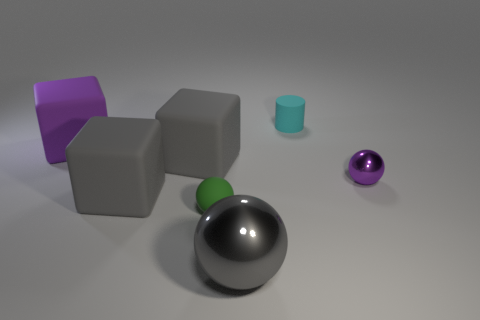What size is the cube that is the same color as the small shiny object?
Give a very brief answer. Large. Is the small cylinder the same color as the large metallic thing?
Your response must be concise. No. Is the purple sphere made of the same material as the gray sphere?
Keep it short and to the point. Yes. Is the number of small cyan rubber cylinders that are behind the rubber cylinder less than the number of objects right of the big purple cube?
Keep it short and to the point. Yes. What material is the sphere that is to the left of the gray object that is in front of the small matte object that is on the left side of the gray sphere?
Ensure brevity in your answer.  Rubber. How many objects are either purple metal objects behind the gray sphere or tiny shiny balls behind the matte sphere?
Provide a short and direct response. 1. There is another tiny thing that is the same shape as the green matte thing; what material is it?
Ensure brevity in your answer.  Metal. What number of shiny objects are big purple objects or blue objects?
Make the answer very short. 0. The other small object that is made of the same material as the cyan thing is what shape?
Your answer should be very brief. Sphere. What number of other purple things have the same shape as the purple matte object?
Your answer should be compact. 0. 